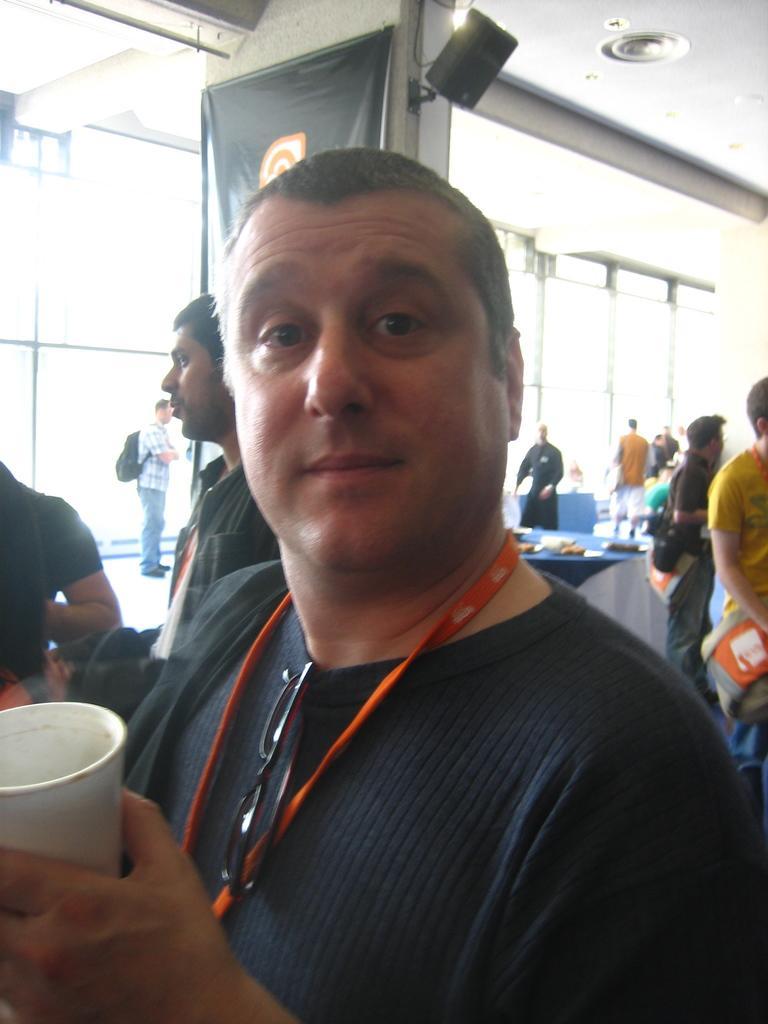In one or two sentences, can you explain what this image depicts? In this image we can see a man holding a glass. On the backside we can see a group of people, a table containing some objects on it, a banner, speaker box and a roof. 